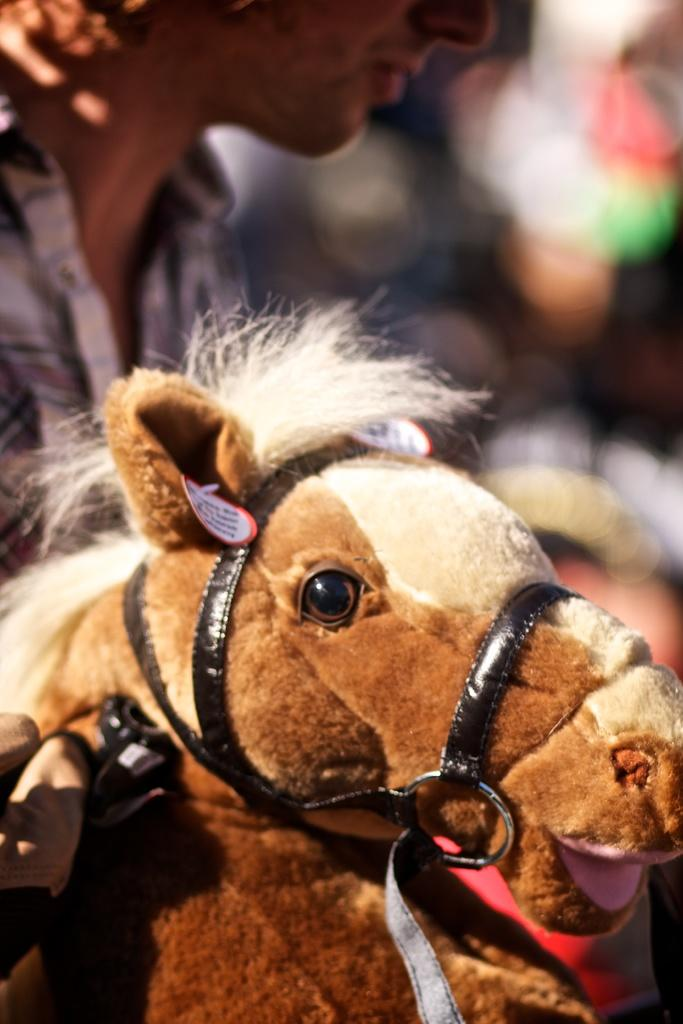What is the main subject in the image? There is a horse toy in the image. Can you describe the setting or environment in the image? There is a person in the background of the image. What type of bedroom furniture can be seen in the image? There is no bedroom furniture present in the image; it features a horse toy and a person in the background. 